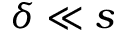<formula> <loc_0><loc_0><loc_500><loc_500>\delta \ll s</formula> 